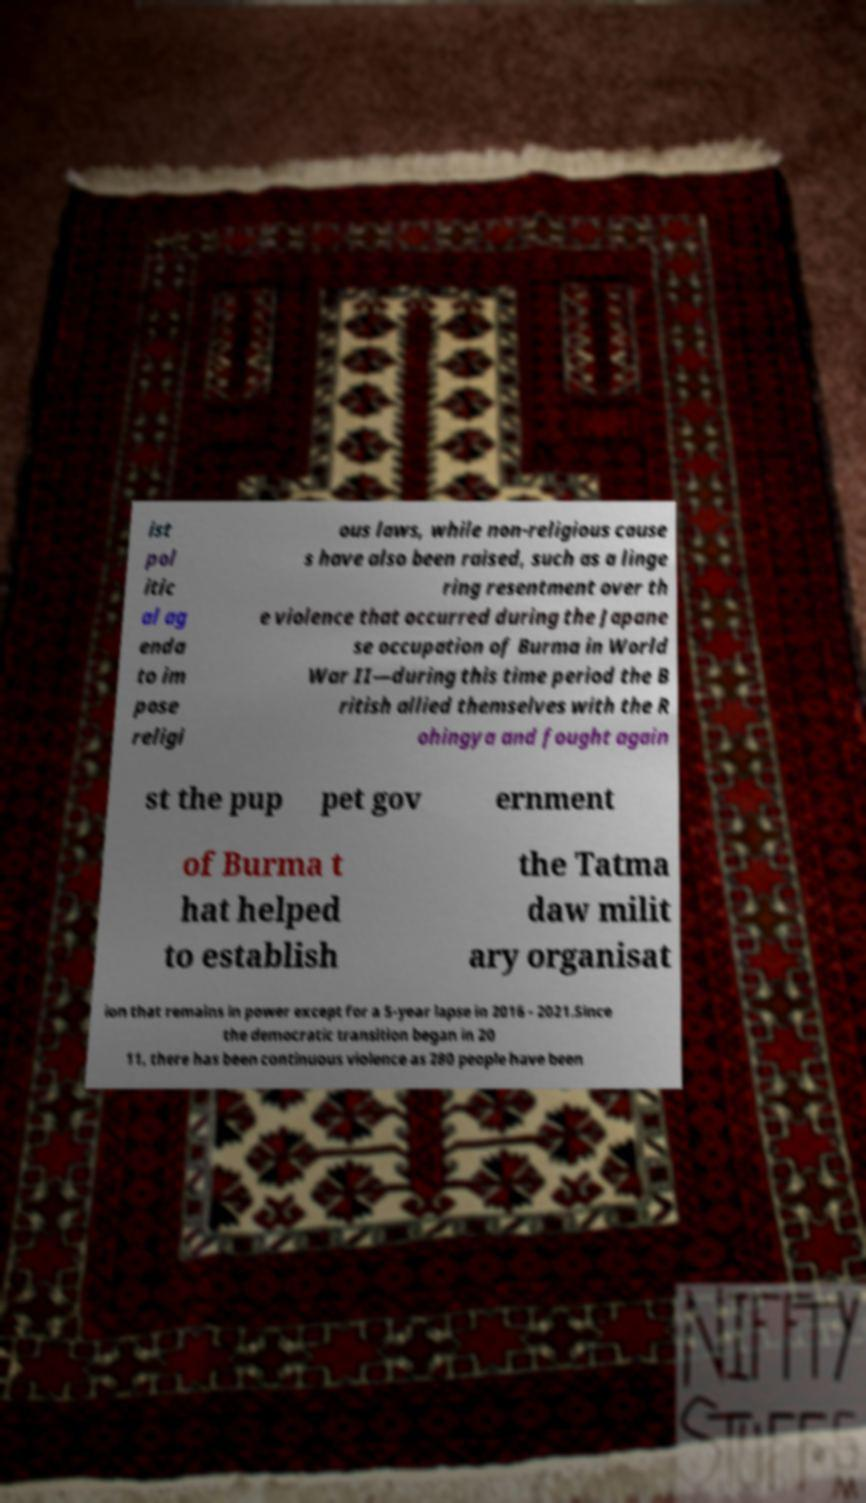Could you extract and type out the text from this image? ist pol itic al ag enda to im pose religi ous laws, while non-religious cause s have also been raised, such as a linge ring resentment over th e violence that occurred during the Japane se occupation of Burma in World War II—during this time period the B ritish allied themselves with the R ohingya and fought again st the pup pet gov ernment of Burma t hat helped to establish the Tatma daw milit ary organisat ion that remains in power except for a 5-year lapse in 2016 - 2021.Since the democratic transition began in 20 11, there has been continuous violence as 280 people have been 